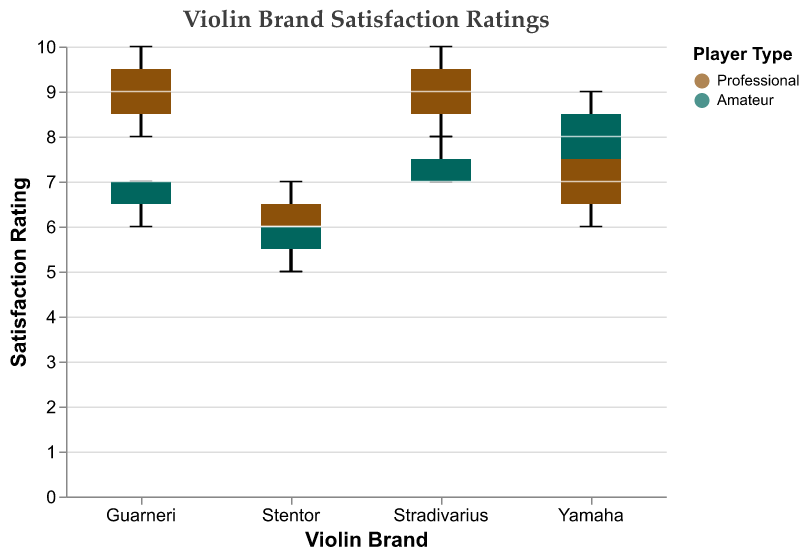Which Player Type has a higher median Satisfaction Rating for Stradivarius violins? The median Satisfaction Rating for Stradivarius violins can be identified by examining the middle line in each of the box plots. The middle line for Professionals is higher than that for Amateurs.
Answer: Professional What is the range of Satisfaction Ratings for Professional players using Yamaha violins? The range of Satisfaction Ratings for Professional players using Yamaha violins is given by the distance between the minimum and the maximum values for the box plot. The minimum rating is 6, and the maximum is 8.
Answer: 2 Which violin brand has the lowest median Satisfaction Rating for Amateur players? To find the lowest median Satisfaction Rating for Amateur players, look at the middle lines of the box plots for all brands for Amateurs. The Stentor brand has the lowest median line.
Answer: Stentor Is there a brand where both Professional and Amateur players have the same median Satisfaction Rating? Compare the middle lines of the box plots for both Professional and Amateur players for each brand. For the Yamaha brand, the median lines for both Professional and Amateur players are identical.
Answer: Yes, Yamaha What is the interquartile range (IQR) of Satisfaction Ratings for Professional players using Guarneri violins? The IQR is the range between the first quartile (Q1) and the third quartile (Q3). For Professional players using Guarneri violins, Q1 is 8 and Q3 is 10, so the IQR is 10 - 8.
Answer: 2 Which violin brand shows the widest range of Satisfaction Ratings for Amateur players? The widest range is determined by looking at the length of the box plot whiskers. Guarneri for Amateur players has the widest range from 6 to 7.
Answer: Guarneri Are there any outliers for Professional players using Stentor violins? Outliers would be visible as dots outside the whiskers of the box plot. There are no dots outside the whiskers for Professional users of Stentor violins.
Answer: No Which group (Professional or Amateur) has a higher variability in Satisfaction Ratings for Stradivarius violins? Variability is indicated by the length of the whiskers. For Stradivarius violins, Amateur players have longer whiskers than Professional players.
Answer: Amateur How does the median Satisfaction Rating of Professional players compare between Stradivarius and Guarneri violins? By comparing the middle lines of the box plots for Professionals playing Stradivarius and Guarneri violins, we see that both medians are very similar, with both centered close to 9.
Answer: Similar 